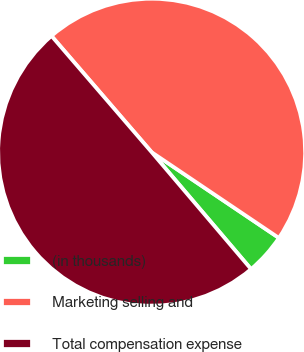Convert chart to OTSL. <chart><loc_0><loc_0><loc_500><loc_500><pie_chart><fcel>(in thousands)<fcel>Marketing selling and<fcel>Total compensation expense<nl><fcel>4.35%<fcel>45.76%<fcel>49.9%<nl></chart> 